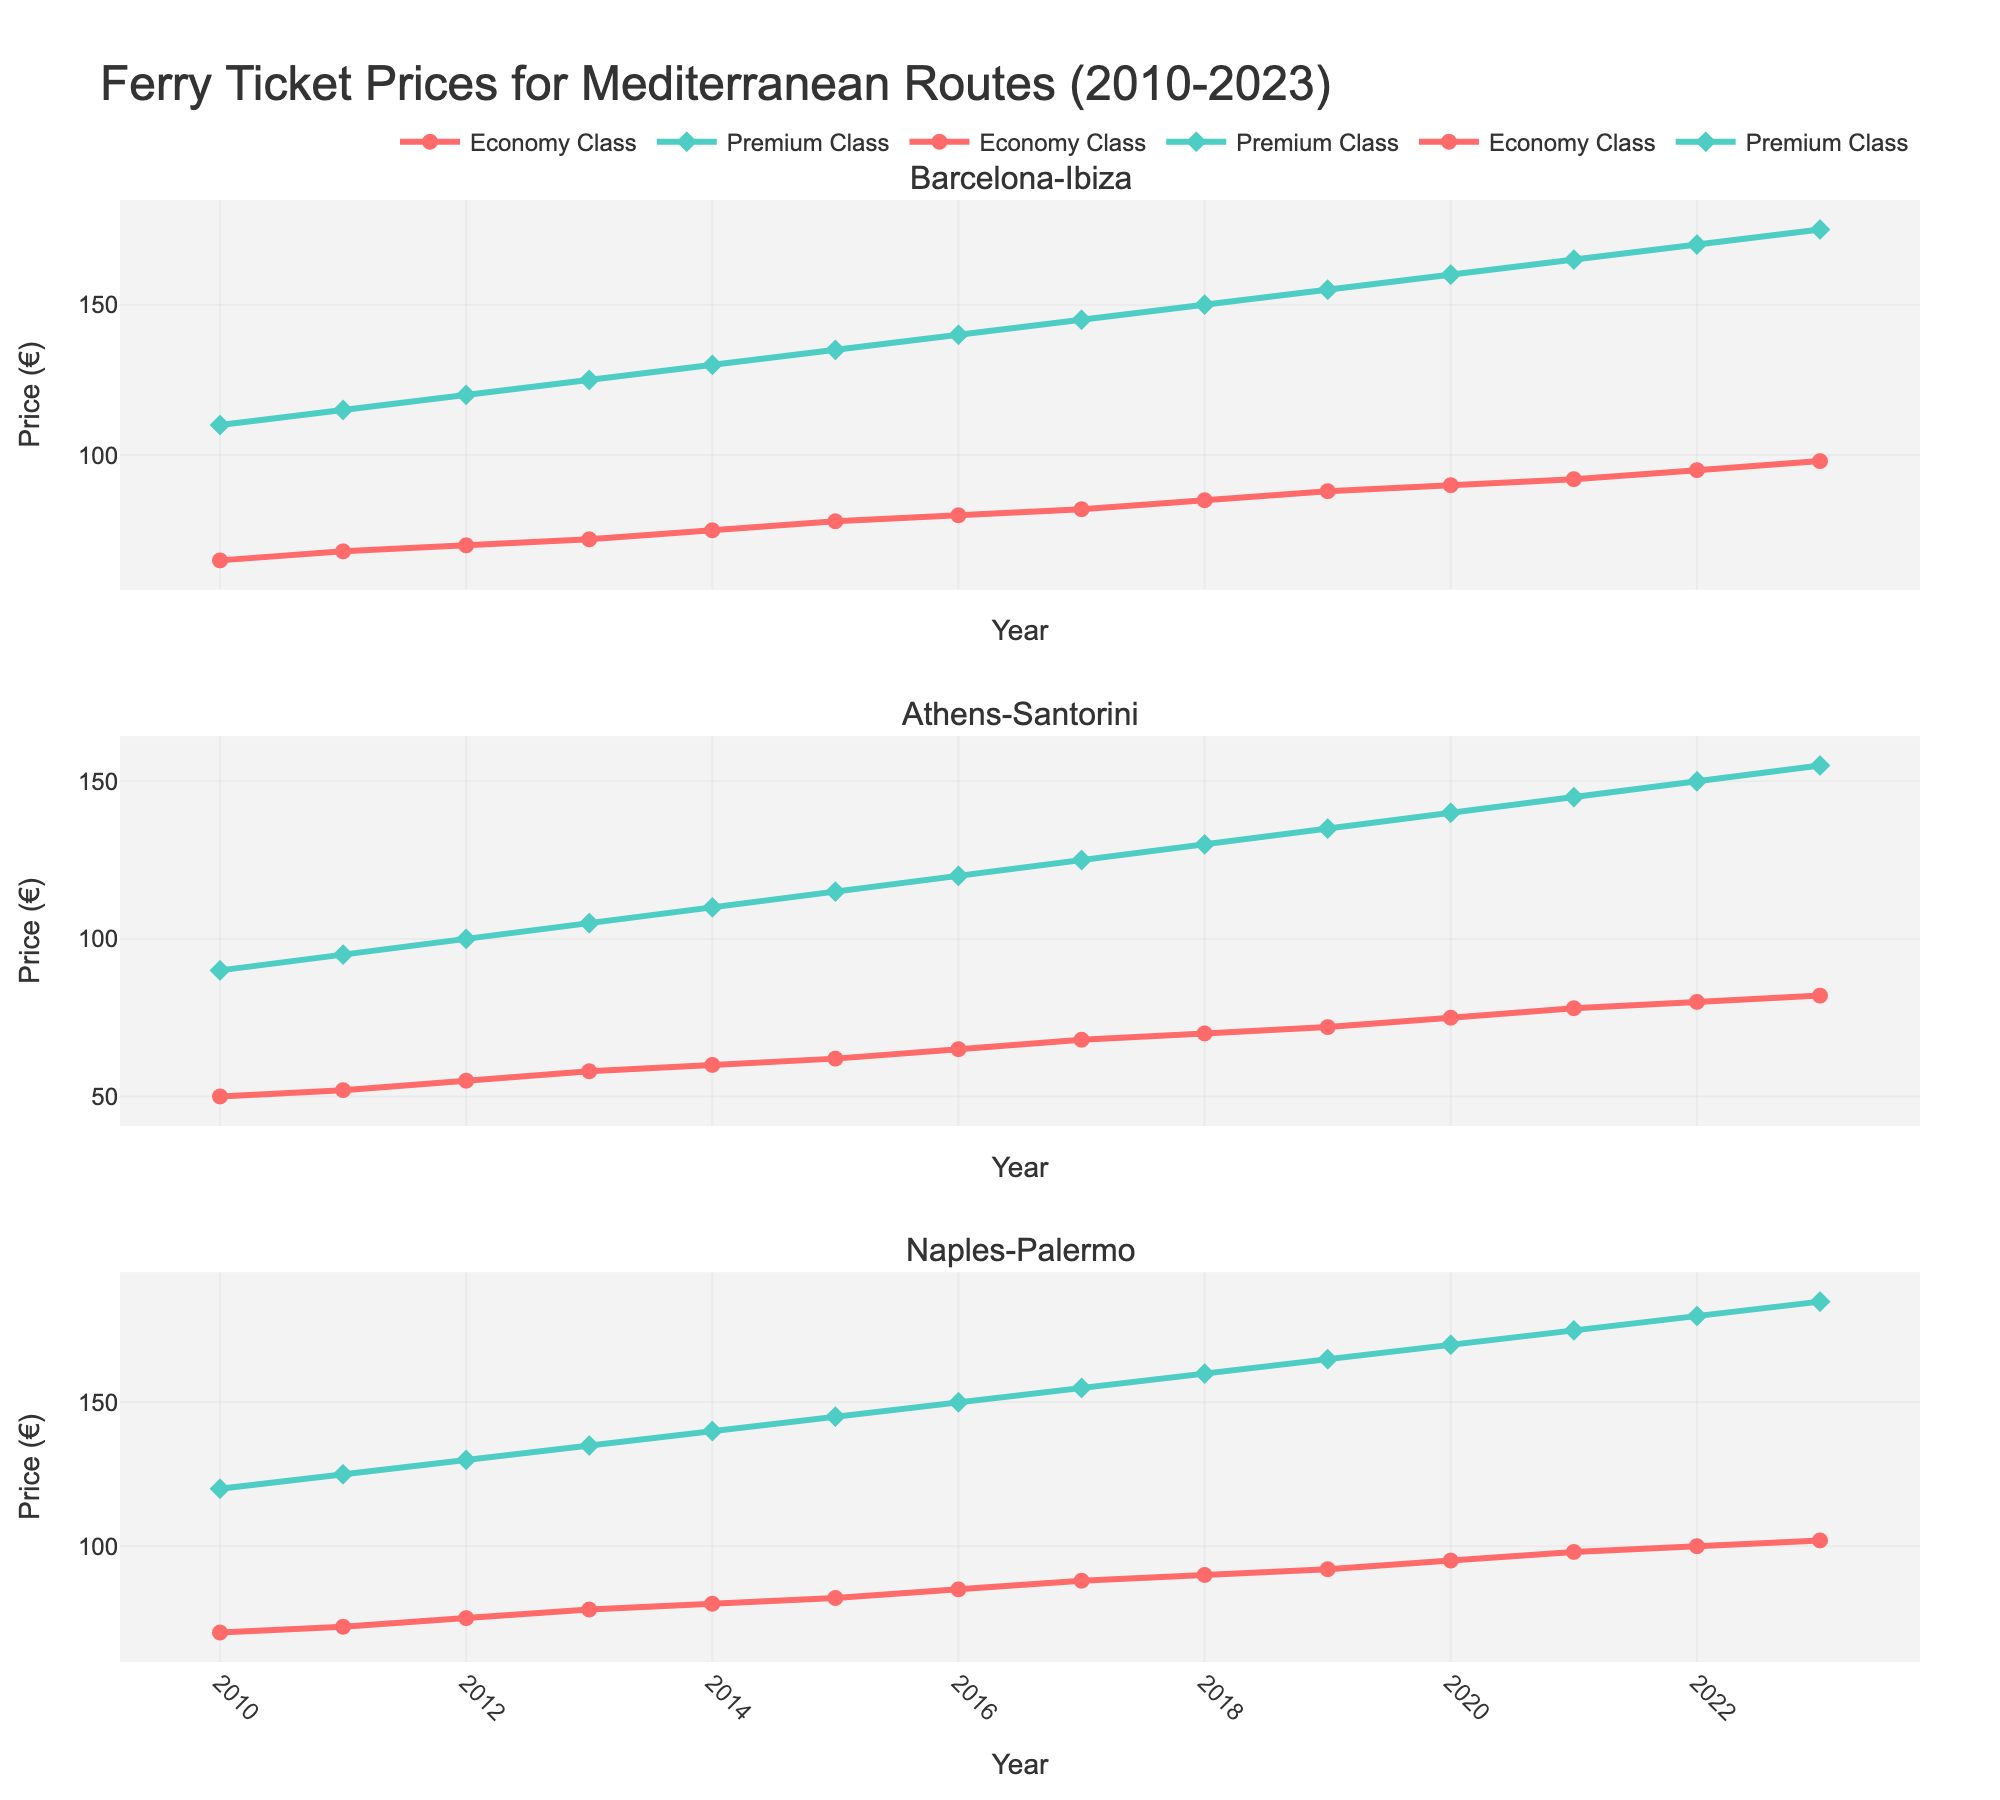What's the average ticket price for Economy Class on the Barcelona-Ibiza route from 2010 to 2023? To find the average ticket price, sum up all the ticket prices from 2010 to 2023 and divide by the number of years. That is (65 + 68 + 70 + 72 + 75 + 78 + 80 + 82 + 85 + 88 + 90 + 92 + 95 + 98) / 14 = 1128 / 14
Answer: 80.57 Which route experienced the highest increase in Premium Class prices from 2010 to 2023? To determine the highest increase, subtract the 2010 price from the 2023 price for each route. For Barcelona-Ibiza: 175 - 110 = 65, for Athens-Santorini: 155 - 90 = 65, and for Naples-Palermo: 185 - 120 = 65. All routes had the same increase.
Answer: All routes What was the ticket price difference between Economy and Premium classes for the Naples-Palermo route in 2013? Find the difference between the Premium and Economy prices for Naples-Palermo in 2013, which is 135 - 78 = 57
Answer: 57 Which year shows the highest Premium Class ticket price for the Athens-Santorini route? Scan through the Premium Class prices for Athens-Santorini and identify the maximum value and the corresponding year. The highest price is 155 in the year 2023
Answer: 2023 How did the Economy Class price trend for the Barcelona-Ibiza route change over the years from 2010 to 2023? Observe the line of Economy Class for Barcelona-Ibiza. The trend shows a consistent increase from 65 in 2010 to 98 in 2023.
Answer: Increasing In which year did the Economy Class price for the Naples-Palermo route first exceed 80 euros? Identify the first year the Economy Class price for Naples-Palermo goes above 80 euros. The price was 85 in 2016
Answer: 2016 Compare the Economy Class price trends for all routes in 2020. Which route had the lowest price? Check the prices for all routes in 2020, and identify the lowest one. Barcelona-Ibiza: 90, Athens-Santorini: 75, Naples-Palermo: 95. The lowest is Athens-Santorini with 75 euros.
Answer: Athens-Santorini What's the total increase in the Economy Class price for the Athens-Santorini route from 2010 to 2023? Subtract the 2010 price from the 2023 price for Athens-Santorini. 82 - 50 = 32
Answer: 32 